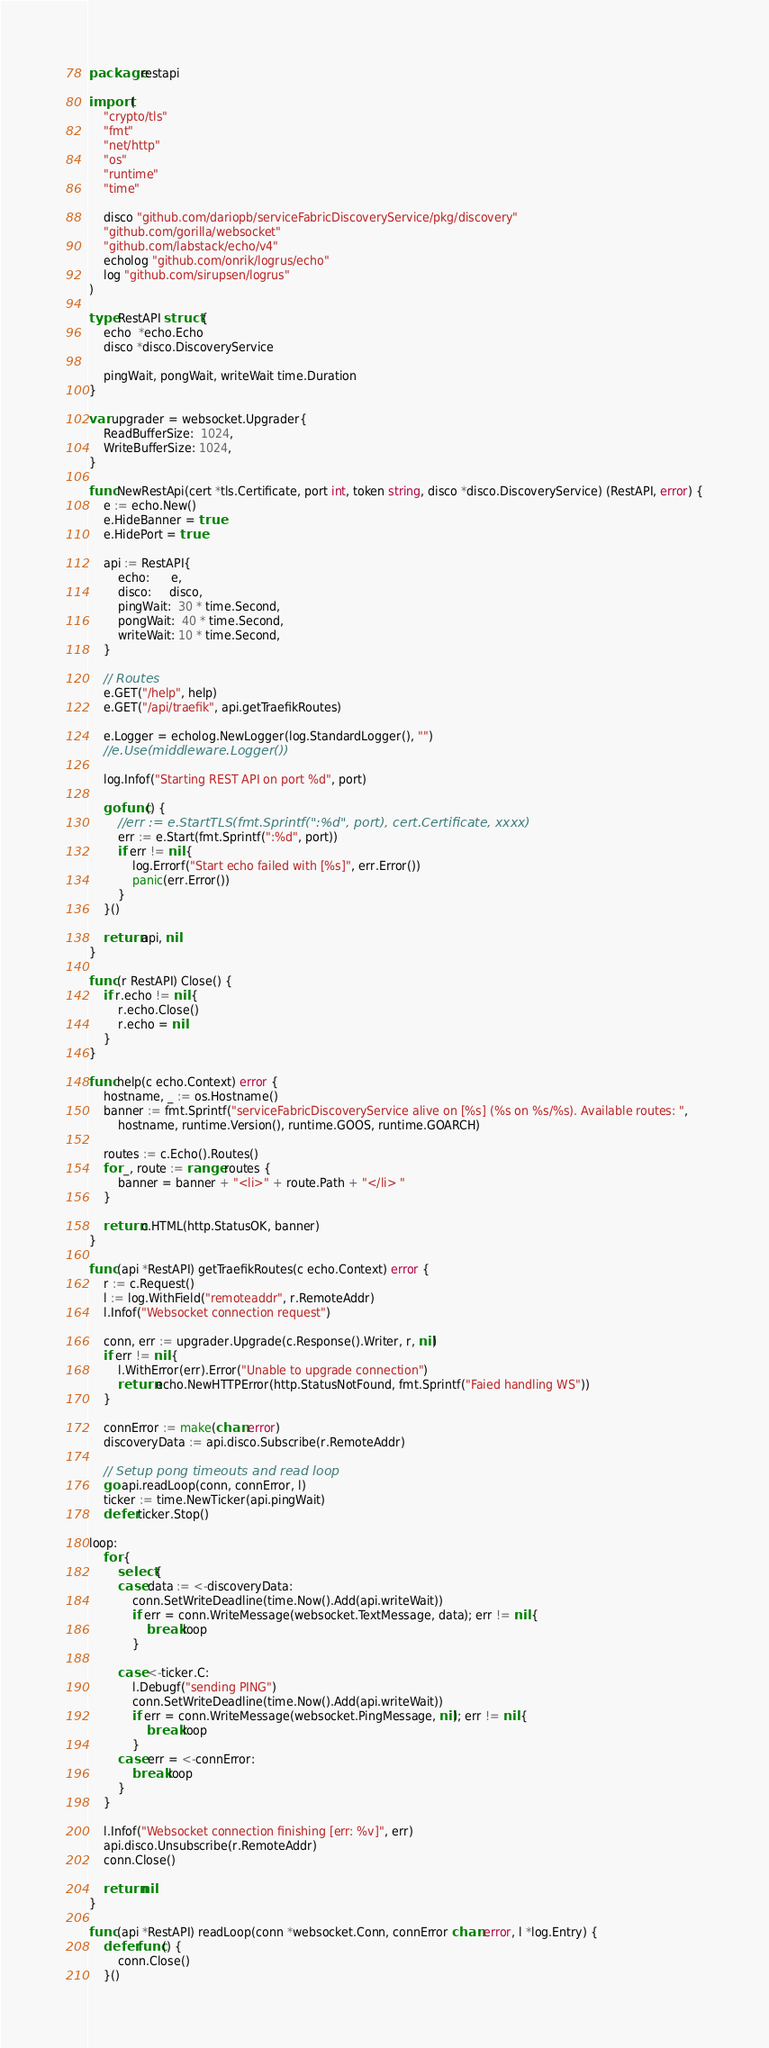Convert code to text. <code><loc_0><loc_0><loc_500><loc_500><_Go_>package restapi

import (
	"crypto/tls"
	"fmt"
	"net/http"
	"os"
	"runtime"
	"time"

	disco "github.com/dariopb/serviceFabricDiscoveryService/pkg/discovery"
	"github.com/gorilla/websocket"
	"github.com/labstack/echo/v4"
	echolog "github.com/onrik/logrus/echo"
	log "github.com/sirupsen/logrus"
)

type RestAPI struct {
	echo  *echo.Echo
	disco *disco.DiscoveryService

	pingWait, pongWait, writeWait time.Duration
}

var upgrader = websocket.Upgrader{
	ReadBufferSize:  1024,
	WriteBufferSize: 1024,
}

func NewRestApi(cert *tls.Certificate, port int, token string, disco *disco.DiscoveryService) (RestAPI, error) {
	e := echo.New()
	e.HideBanner = true
	e.HidePort = true

	api := RestAPI{
		echo:      e,
		disco:     disco,
		pingWait:  30 * time.Second,
		pongWait:  40 * time.Second,
		writeWait: 10 * time.Second,
	}

	// Routes
	e.GET("/help", help)
	e.GET("/api/traefik", api.getTraefikRoutes)

	e.Logger = echolog.NewLogger(log.StandardLogger(), "")
	//e.Use(middleware.Logger())

	log.Infof("Starting REST API on port %d", port)

	go func() {
		//err := e.StartTLS(fmt.Sprintf(":%d", port), cert.Certificate, xxxx)
		err := e.Start(fmt.Sprintf(":%d", port))
		if err != nil {
			log.Errorf("Start echo failed with [%s]", err.Error())
			panic(err.Error())
		}
	}()

	return api, nil
}

func (r RestAPI) Close() {
	if r.echo != nil {
		r.echo.Close()
		r.echo = nil
	}
}

func help(c echo.Context) error {
	hostname, _ := os.Hostname()
	banner := fmt.Sprintf("serviceFabricDiscoveryService alive on [%s] (%s on %s/%s). Available routes: ",
		hostname, runtime.Version(), runtime.GOOS, runtime.GOARCH)

	routes := c.Echo().Routes()
	for _, route := range routes {
		banner = banner + "<li>" + route.Path + "</li> "
	}

	return c.HTML(http.StatusOK, banner)
}

func (api *RestAPI) getTraefikRoutes(c echo.Context) error {
	r := c.Request()
	l := log.WithField("remoteaddr", r.RemoteAddr)
	l.Infof("Websocket connection request")

	conn, err := upgrader.Upgrade(c.Response().Writer, r, nil)
	if err != nil {
		l.WithError(err).Error("Unable to upgrade connection")
		return echo.NewHTTPError(http.StatusNotFound, fmt.Sprintf("Faied handling WS"))
	}

	connError := make(chan error)
	discoveryData := api.disco.Subscribe(r.RemoteAddr)

	// Setup pong timeouts and read loop
	go api.readLoop(conn, connError, l)
	ticker := time.NewTicker(api.pingWait)
	defer ticker.Stop()

loop:
	for {
		select {
		case data := <-discoveryData:
			conn.SetWriteDeadline(time.Now().Add(api.writeWait))
			if err = conn.WriteMessage(websocket.TextMessage, data); err != nil {
				break loop
			}

		case <-ticker.C:
			l.Debugf("sending PING")
			conn.SetWriteDeadline(time.Now().Add(api.writeWait))
			if err = conn.WriteMessage(websocket.PingMessage, nil); err != nil {
				break loop
			}
		case err = <-connError:
			break loop
		}
	}

	l.Infof("Websocket connection finishing [err: %v]", err)
	api.disco.Unsubscribe(r.RemoteAddr)
	conn.Close()

	return nil
}

func (api *RestAPI) readLoop(conn *websocket.Conn, connError chan error, l *log.Entry) {
	defer func() {
		conn.Close()
	}()
</code> 